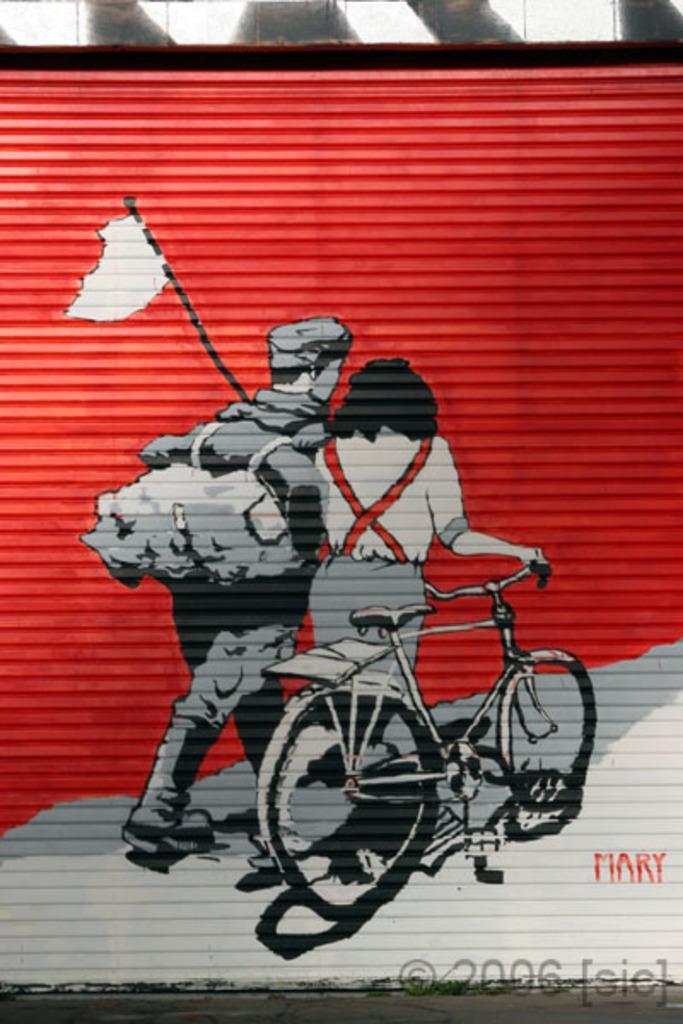In one or two sentences, can you explain what this image depicts? In the foreground of this image, it seems like painting on the shutter. At the top, there is the wall. At the bottom, there is the road. 